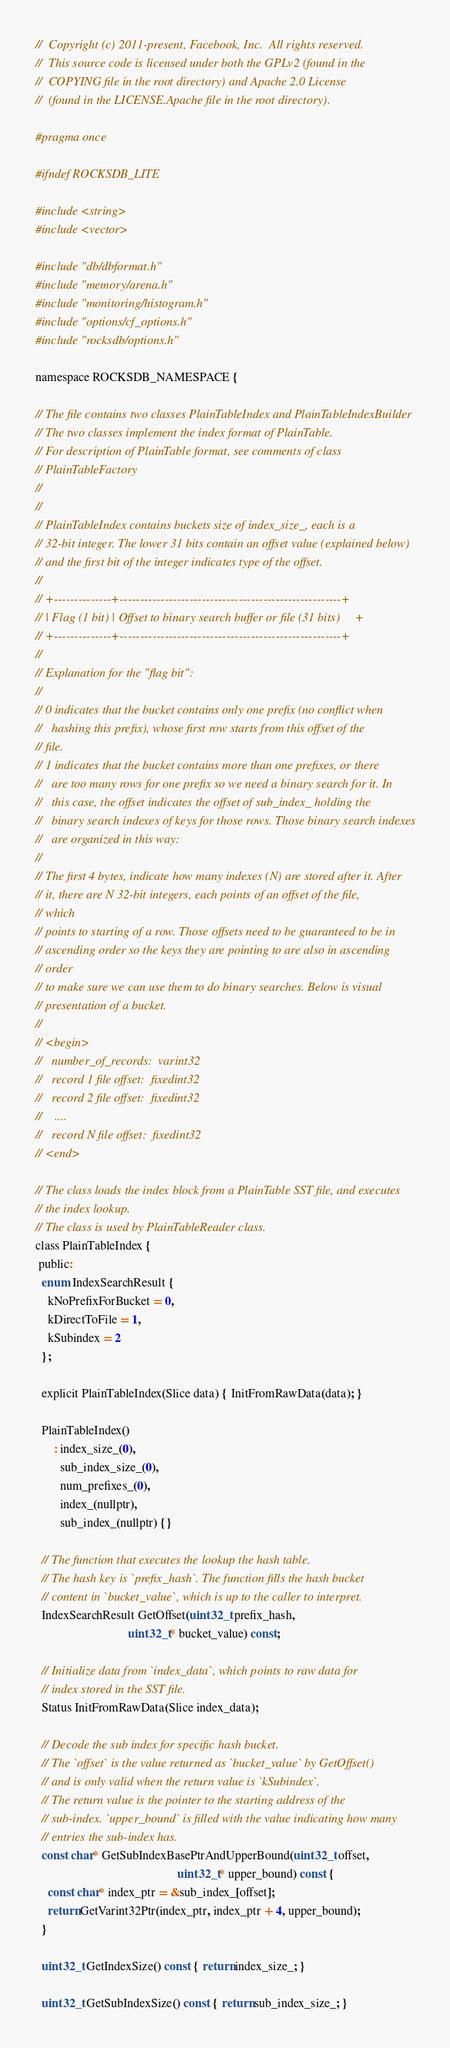Convert code to text. <code><loc_0><loc_0><loc_500><loc_500><_C_>//  Copyright (c) 2011-present, Facebook, Inc.  All rights reserved.
//  This source code is licensed under both the GPLv2 (found in the
//  COPYING file in the root directory) and Apache 2.0 License
//  (found in the LICENSE.Apache file in the root directory).

#pragma once

#ifndef ROCKSDB_LITE

#include <string>
#include <vector>

#include "db/dbformat.h"
#include "memory/arena.h"
#include "monitoring/histogram.h"
#include "options/cf_options.h"
#include "rocksdb/options.h"

namespace ROCKSDB_NAMESPACE {

// The file contains two classes PlainTableIndex and PlainTableIndexBuilder
// The two classes implement the index format of PlainTable.
// For description of PlainTable format, see comments of class
// PlainTableFactory
//
//
// PlainTableIndex contains buckets size of index_size_, each is a
// 32-bit integer. The lower 31 bits contain an offset value (explained below)
// and the first bit of the integer indicates type of the offset.
//
// +--------------+------------------------------------------------------+
// | Flag (1 bit) | Offset to binary search buffer or file (31 bits)     +
// +--------------+------------------------------------------------------+
//
// Explanation for the "flag bit":
//
// 0 indicates that the bucket contains only one prefix (no conflict when
//   hashing this prefix), whose first row starts from this offset of the
// file.
// 1 indicates that the bucket contains more than one prefixes, or there
//   are too many rows for one prefix so we need a binary search for it. In
//   this case, the offset indicates the offset of sub_index_ holding the
//   binary search indexes of keys for those rows. Those binary search indexes
//   are organized in this way:
//
// The first 4 bytes, indicate how many indexes (N) are stored after it. After
// it, there are N 32-bit integers, each points of an offset of the file,
// which
// points to starting of a row. Those offsets need to be guaranteed to be in
// ascending order so the keys they are pointing to are also in ascending
// order
// to make sure we can use them to do binary searches. Below is visual
// presentation of a bucket.
//
// <begin>
//   number_of_records:  varint32
//   record 1 file offset:  fixedint32
//   record 2 file offset:  fixedint32
//    ....
//   record N file offset:  fixedint32
// <end>

// The class loads the index block from a PlainTable SST file, and executes
// the index lookup.
// The class is used by PlainTableReader class.
class PlainTableIndex {
 public:
  enum IndexSearchResult {
    kNoPrefixForBucket = 0,
    kDirectToFile = 1,
    kSubindex = 2
  };

  explicit PlainTableIndex(Slice data) { InitFromRawData(data); }

  PlainTableIndex()
      : index_size_(0),
        sub_index_size_(0),
        num_prefixes_(0),
        index_(nullptr),
        sub_index_(nullptr) {}

  // The function that executes the lookup the hash table.
  // The hash key is `prefix_hash`. The function fills the hash bucket
  // content in `bucket_value`, which is up to the caller to interpret.
  IndexSearchResult GetOffset(uint32_t prefix_hash,
                              uint32_t* bucket_value) const;

  // Initialize data from `index_data`, which points to raw data for
  // index stored in the SST file.
  Status InitFromRawData(Slice index_data);

  // Decode the sub index for specific hash bucket.
  // The `offset` is the value returned as `bucket_value` by GetOffset()
  // and is only valid when the return value is `kSubindex`.
  // The return value is the pointer to the starting address of the
  // sub-index. `upper_bound` is filled with the value indicating how many
  // entries the sub-index has.
  const char* GetSubIndexBasePtrAndUpperBound(uint32_t offset,
                                              uint32_t* upper_bound) const {
    const char* index_ptr = &sub_index_[offset];
    return GetVarint32Ptr(index_ptr, index_ptr + 4, upper_bound);
  }

  uint32_t GetIndexSize() const { return index_size_; }

  uint32_t GetSubIndexSize() const { return sub_index_size_; }
</code> 